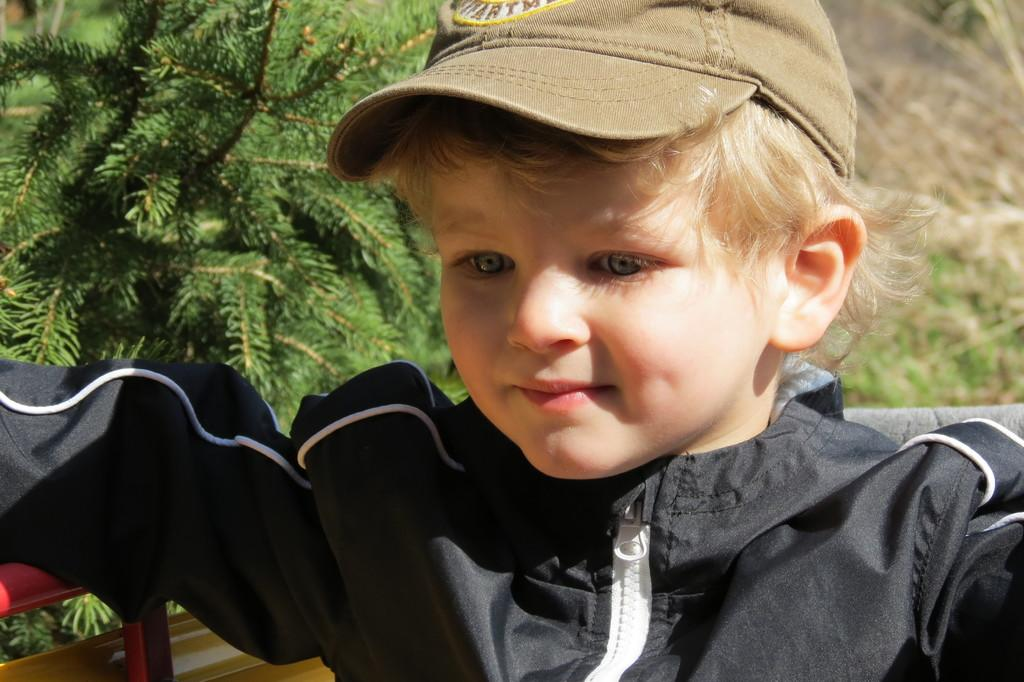What is the main subject of the image? The main subject of the image is a kid. What is the kid wearing in the image? The kid is wearing a black dress in the image. What can be seen in the background of the image? There is a plant in the background of the image. What type of metal is the kid crushing with their nose in the image? There is no metal or any crushing action involving the kid's nose in the image. 